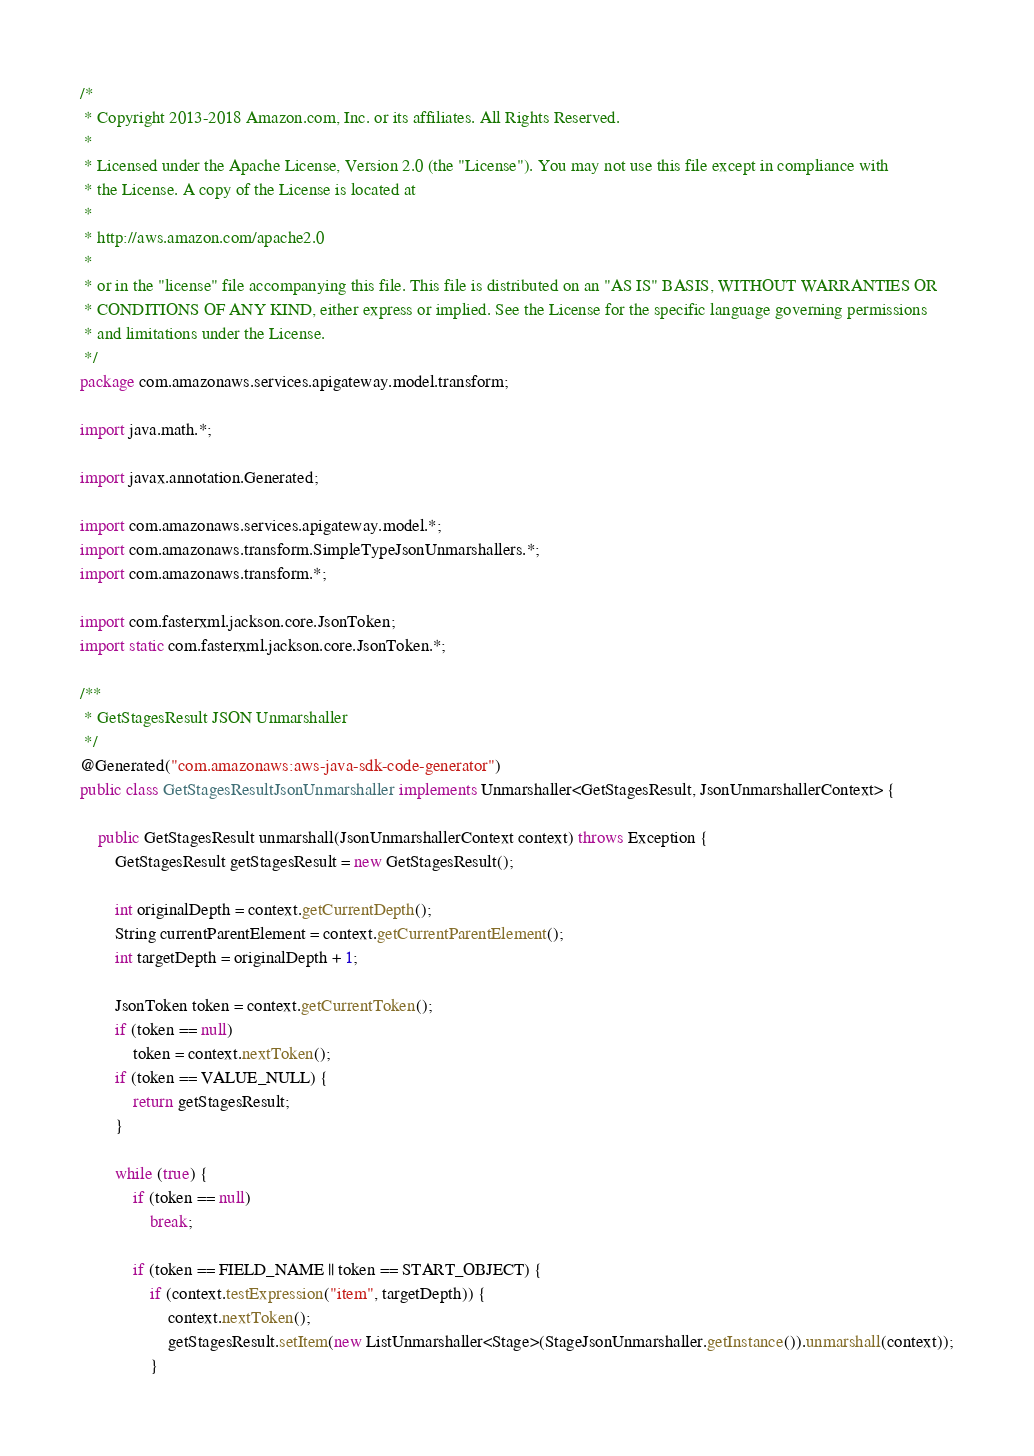<code> <loc_0><loc_0><loc_500><loc_500><_Java_>/*
 * Copyright 2013-2018 Amazon.com, Inc. or its affiliates. All Rights Reserved.
 * 
 * Licensed under the Apache License, Version 2.0 (the "License"). You may not use this file except in compliance with
 * the License. A copy of the License is located at
 * 
 * http://aws.amazon.com/apache2.0
 * 
 * or in the "license" file accompanying this file. This file is distributed on an "AS IS" BASIS, WITHOUT WARRANTIES OR
 * CONDITIONS OF ANY KIND, either express or implied. See the License for the specific language governing permissions
 * and limitations under the License.
 */
package com.amazonaws.services.apigateway.model.transform;

import java.math.*;

import javax.annotation.Generated;

import com.amazonaws.services.apigateway.model.*;
import com.amazonaws.transform.SimpleTypeJsonUnmarshallers.*;
import com.amazonaws.transform.*;

import com.fasterxml.jackson.core.JsonToken;
import static com.fasterxml.jackson.core.JsonToken.*;

/**
 * GetStagesResult JSON Unmarshaller
 */
@Generated("com.amazonaws:aws-java-sdk-code-generator")
public class GetStagesResultJsonUnmarshaller implements Unmarshaller<GetStagesResult, JsonUnmarshallerContext> {

    public GetStagesResult unmarshall(JsonUnmarshallerContext context) throws Exception {
        GetStagesResult getStagesResult = new GetStagesResult();

        int originalDepth = context.getCurrentDepth();
        String currentParentElement = context.getCurrentParentElement();
        int targetDepth = originalDepth + 1;

        JsonToken token = context.getCurrentToken();
        if (token == null)
            token = context.nextToken();
        if (token == VALUE_NULL) {
            return getStagesResult;
        }

        while (true) {
            if (token == null)
                break;

            if (token == FIELD_NAME || token == START_OBJECT) {
                if (context.testExpression("item", targetDepth)) {
                    context.nextToken();
                    getStagesResult.setItem(new ListUnmarshaller<Stage>(StageJsonUnmarshaller.getInstance()).unmarshall(context));
                }</code> 